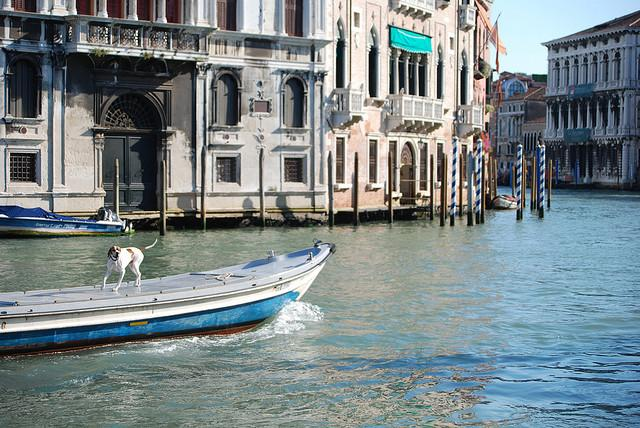What are these waterways equivalent in usage to in other cities and countries? roads 